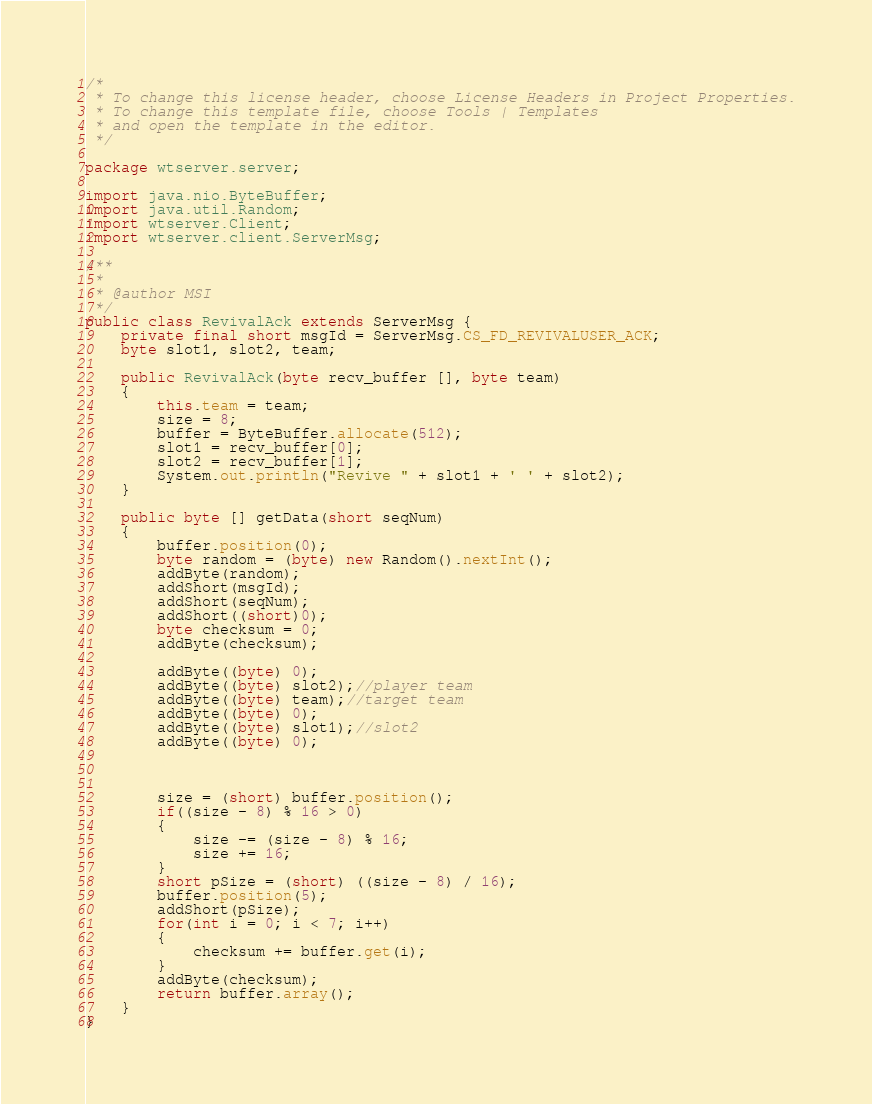<code> <loc_0><loc_0><loc_500><loc_500><_Java_>/*
 * To change this license header, choose License Headers in Project Properties.
 * To change this template file, choose Tools | Templates
 * and open the template in the editor.
 */

package wtserver.server;

import java.nio.ByteBuffer;
import java.util.Random;
import wtserver.Client;
import wtserver.client.ServerMsg;

/**
 *
 * @author MSI
 */
public class RevivalAck extends ServerMsg {
    private final short msgId = ServerMsg.CS_FD_REVIVALUSER_ACK;
    byte slot1, slot2, team;
    
    public RevivalAck(byte recv_buffer [], byte team)
    {
        this.team = team;
        size = 8;
        buffer = ByteBuffer.allocate(512);
        slot1 = recv_buffer[0];
        slot2 = recv_buffer[1];
        System.out.println("Revive " + slot1 + ' ' + slot2);
    }
    
    public byte [] getData(short seqNum)
    {
        buffer.position(0);
        byte random = (byte) new Random().nextInt();
        addByte(random);
        addShort(msgId);
        addShort(seqNum);
        addShort((short)0);
        byte checksum = 0;
        addByte(checksum);
        
        addByte((byte) 0);
        addByte((byte) slot2);//player team
        addByte((byte) team);//target team
        addByte((byte) 0);
        addByte((byte) slot1);//slot2
        addByte((byte) 0);
        
        
        
        size = (short) buffer.position();
        if((size - 8) % 16 > 0)
        {
            size -= (size - 8) % 16;
            size += 16;
        }
        short pSize = (short) ((size - 8) / 16);
        buffer.position(5);
        addShort(pSize);
        for(int i = 0; i < 7; i++)
        {
            checksum += buffer.get(i);
        }
        addByte(checksum);
        return buffer.array();
    }
}</code> 